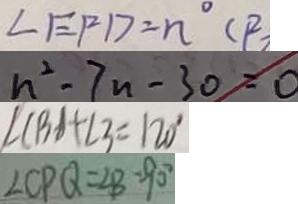<formula> <loc_0><loc_0><loc_500><loc_500>\angle E F D = n ^ { \circ } ( P 
 n ^ { 2 } - 7 n - 3 0 = 0 
 \angle C B A + \angle 3 = 1 2 0 ^ { \circ } 
 \angle C P Q = \angle B = 9 0 ^ { \circ }</formula> 